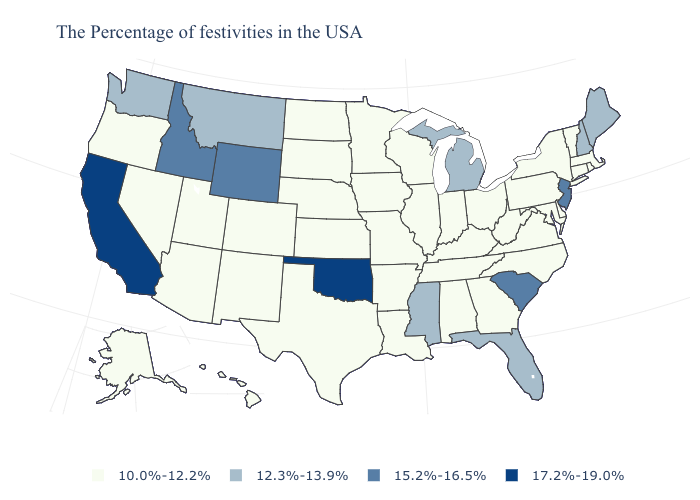Does Illinois have the lowest value in the MidWest?
Keep it brief. Yes. Name the states that have a value in the range 15.2%-16.5%?
Answer briefly. New Jersey, South Carolina, Wyoming, Idaho. Name the states that have a value in the range 12.3%-13.9%?
Quick response, please. Maine, New Hampshire, Florida, Michigan, Mississippi, Montana, Washington. Does the first symbol in the legend represent the smallest category?
Keep it brief. Yes. What is the value of Washington?
Give a very brief answer. 12.3%-13.9%. What is the value of Ohio?
Answer briefly. 10.0%-12.2%. What is the value of Minnesota?
Give a very brief answer. 10.0%-12.2%. Name the states that have a value in the range 17.2%-19.0%?
Answer briefly. Oklahoma, California. Among the states that border Alabama , does Tennessee have the highest value?
Give a very brief answer. No. Name the states that have a value in the range 15.2%-16.5%?
Be succinct. New Jersey, South Carolina, Wyoming, Idaho. Among the states that border Nevada , does Oregon have the lowest value?
Write a very short answer. Yes. Name the states that have a value in the range 12.3%-13.9%?
Write a very short answer. Maine, New Hampshire, Florida, Michigan, Mississippi, Montana, Washington. Which states have the lowest value in the USA?
Concise answer only. Massachusetts, Rhode Island, Vermont, Connecticut, New York, Delaware, Maryland, Pennsylvania, Virginia, North Carolina, West Virginia, Ohio, Georgia, Kentucky, Indiana, Alabama, Tennessee, Wisconsin, Illinois, Louisiana, Missouri, Arkansas, Minnesota, Iowa, Kansas, Nebraska, Texas, South Dakota, North Dakota, Colorado, New Mexico, Utah, Arizona, Nevada, Oregon, Alaska, Hawaii. What is the value of Minnesota?
Be succinct. 10.0%-12.2%. Does New Hampshire have the lowest value in the USA?
Give a very brief answer. No. 